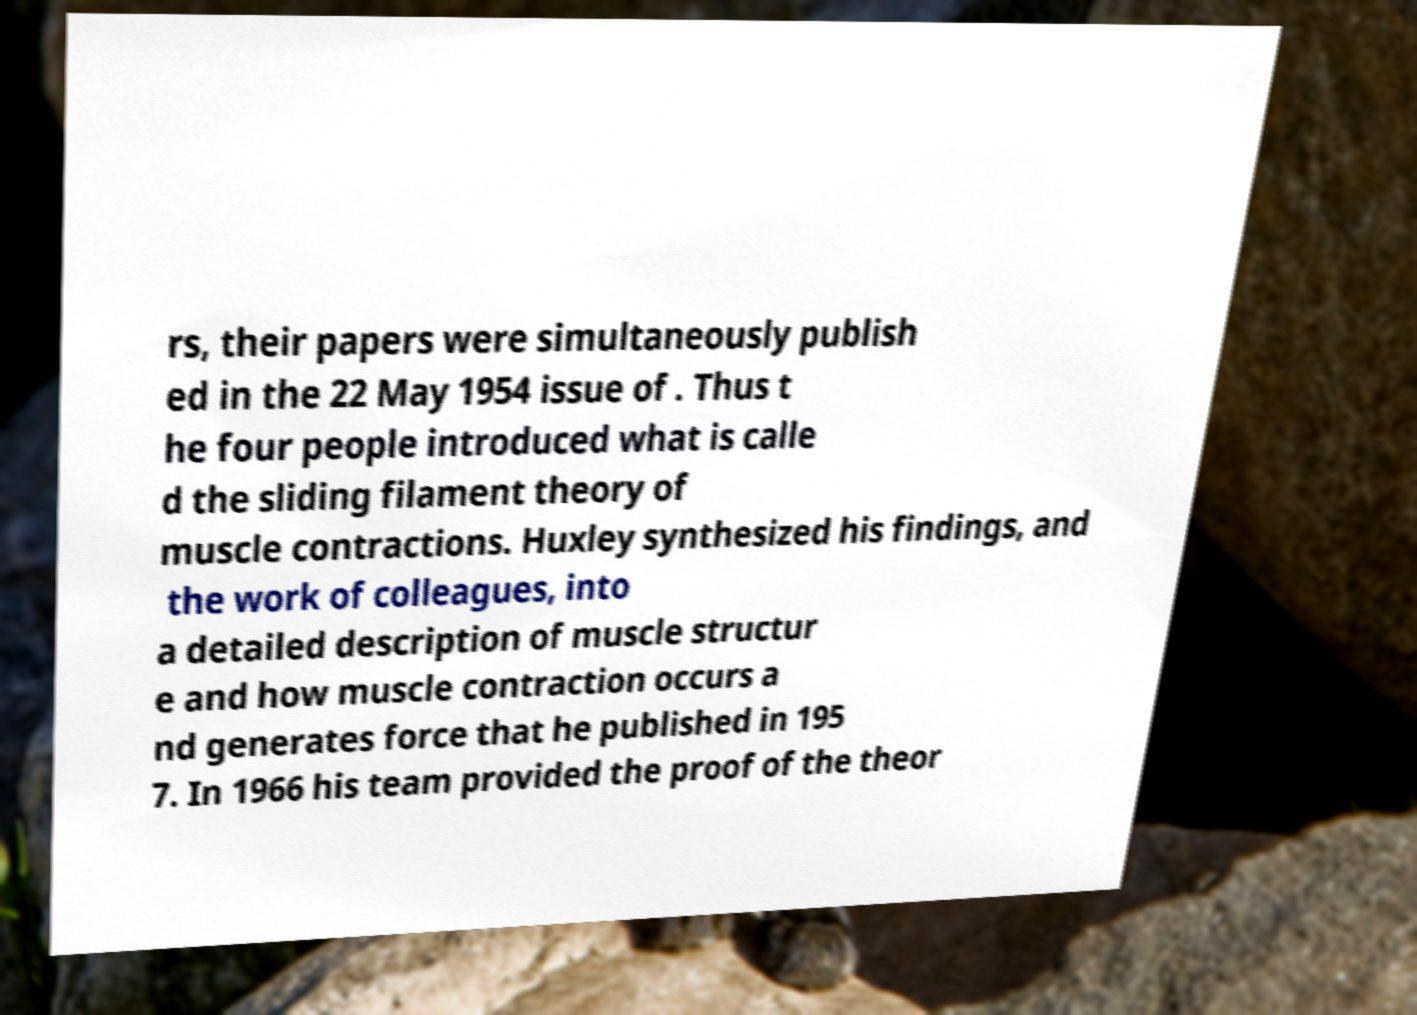Can you read and provide the text displayed in the image?This photo seems to have some interesting text. Can you extract and type it out for me? rs, their papers were simultaneously publish ed in the 22 May 1954 issue of . Thus t he four people introduced what is calle d the sliding filament theory of muscle contractions. Huxley synthesized his findings, and the work of colleagues, into a detailed description of muscle structur e and how muscle contraction occurs a nd generates force that he published in 195 7. In 1966 his team provided the proof of the theor 